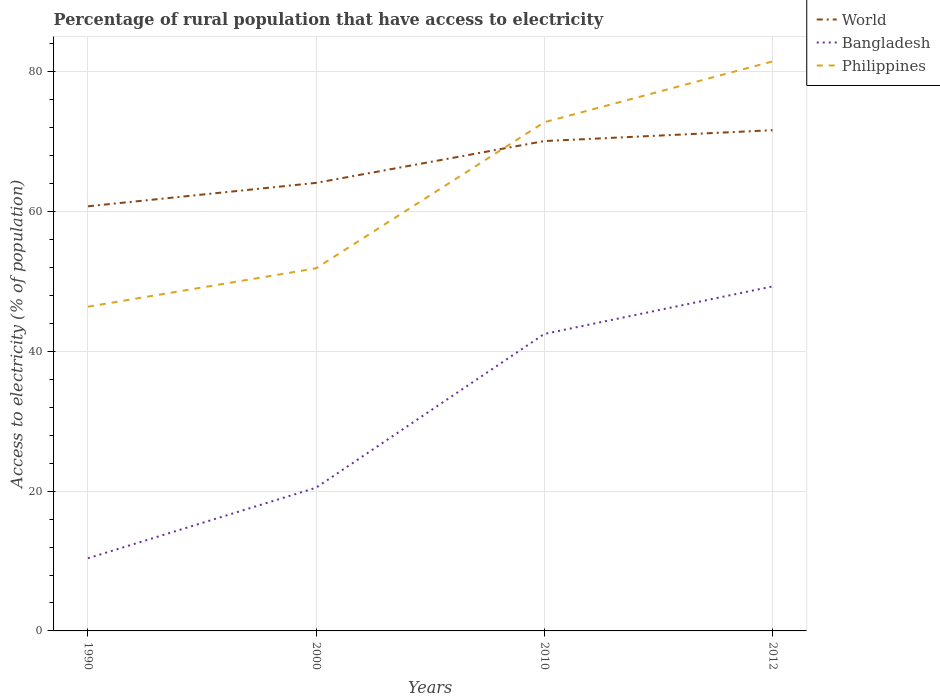How many different coloured lines are there?
Provide a short and direct response. 3. Does the line corresponding to Philippines intersect with the line corresponding to Bangladesh?
Offer a terse response. No. What is the total percentage of rural population that have access to electricity in Bangladesh in the graph?
Provide a succinct answer. -32.1. What is the difference between the highest and the second highest percentage of rural population that have access to electricity in Bangladesh?
Offer a very short reply. 38.9. What is the difference between the highest and the lowest percentage of rural population that have access to electricity in World?
Your response must be concise. 2. How many lines are there?
Keep it short and to the point. 3. What is the difference between two consecutive major ticks on the Y-axis?
Your answer should be compact. 20. Are the values on the major ticks of Y-axis written in scientific E-notation?
Ensure brevity in your answer.  No. Does the graph contain any zero values?
Your answer should be compact. No. Does the graph contain grids?
Ensure brevity in your answer.  Yes. How many legend labels are there?
Your response must be concise. 3. What is the title of the graph?
Keep it short and to the point. Percentage of rural population that have access to electricity. What is the label or title of the X-axis?
Provide a short and direct response. Years. What is the label or title of the Y-axis?
Ensure brevity in your answer.  Access to electricity (% of population). What is the Access to electricity (% of population) in World in 1990?
Your response must be concise. 60.77. What is the Access to electricity (% of population) in Bangladesh in 1990?
Your response must be concise. 10.4. What is the Access to electricity (% of population) of Philippines in 1990?
Your response must be concise. 46.4. What is the Access to electricity (% of population) of World in 2000?
Provide a short and direct response. 64.12. What is the Access to electricity (% of population) in Philippines in 2000?
Provide a succinct answer. 51.9. What is the Access to electricity (% of population) in World in 2010?
Your answer should be compact. 70.1. What is the Access to electricity (% of population) in Bangladesh in 2010?
Your response must be concise. 42.5. What is the Access to electricity (% of population) in Philippines in 2010?
Your answer should be very brief. 72.8. What is the Access to electricity (% of population) in World in 2012?
Provide a short and direct response. 71.66. What is the Access to electricity (% of population) in Bangladesh in 2012?
Offer a very short reply. 49.3. What is the Access to electricity (% of population) of Philippines in 2012?
Offer a terse response. 81.5. Across all years, what is the maximum Access to electricity (% of population) in World?
Ensure brevity in your answer.  71.66. Across all years, what is the maximum Access to electricity (% of population) of Bangladesh?
Keep it short and to the point. 49.3. Across all years, what is the maximum Access to electricity (% of population) in Philippines?
Provide a short and direct response. 81.5. Across all years, what is the minimum Access to electricity (% of population) of World?
Provide a succinct answer. 60.77. Across all years, what is the minimum Access to electricity (% of population) in Bangladesh?
Make the answer very short. 10.4. Across all years, what is the minimum Access to electricity (% of population) of Philippines?
Provide a succinct answer. 46.4. What is the total Access to electricity (% of population) of World in the graph?
Your response must be concise. 266.65. What is the total Access to electricity (% of population) of Bangladesh in the graph?
Keep it short and to the point. 122.7. What is the total Access to electricity (% of population) in Philippines in the graph?
Make the answer very short. 252.6. What is the difference between the Access to electricity (% of population) in World in 1990 and that in 2000?
Provide a succinct answer. -3.35. What is the difference between the Access to electricity (% of population) in World in 1990 and that in 2010?
Give a very brief answer. -9.34. What is the difference between the Access to electricity (% of population) of Bangladesh in 1990 and that in 2010?
Provide a short and direct response. -32.1. What is the difference between the Access to electricity (% of population) of Philippines in 1990 and that in 2010?
Offer a terse response. -26.4. What is the difference between the Access to electricity (% of population) of World in 1990 and that in 2012?
Ensure brevity in your answer.  -10.89. What is the difference between the Access to electricity (% of population) of Bangladesh in 1990 and that in 2012?
Offer a terse response. -38.9. What is the difference between the Access to electricity (% of population) of Philippines in 1990 and that in 2012?
Make the answer very short. -35.1. What is the difference between the Access to electricity (% of population) in World in 2000 and that in 2010?
Offer a very short reply. -5.98. What is the difference between the Access to electricity (% of population) of Bangladesh in 2000 and that in 2010?
Give a very brief answer. -22. What is the difference between the Access to electricity (% of population) in Philippines in 2000 and that in 2010?
Keep it short and to the point. -20.9. What is the difference between the Access to electricity (% of population) in World in 2000 and that in 2012?
Offer a terse response. -7.54. What is the difference between the Access to electricity (% of population) of Bangladesh in 2000 and that in 2012?
Ensure brevity in your answer.  -28.8. What is the difference between the Access to electricity (% of population) of Philippines in 2000 and that in 2012?
Keep it short and to the point. -29.6. What is the difference between the Access to electricity (% of population) of World in 2010 and that in 2012?
Your answer should be very brief. -1.56. What is the difference between the Access to electricity (% of population) of Bangladesh in 2010 and that in 2012?
Offer a very short reply. -6.8. What is the difference between the Access to electricity (% of population) of Philippines in 2010 and that in 2012?
Offer a very short reply. -8.7. What is the difference between the Access to electricity (% of population) of World in 1990 and the Access to electricity (% of population) of Bangladesh in 2000?
Offer a very short reply. 40.27. What is the difference between the Access to electricity (% of population) of World in 1990 and the Access to electricity (% of population) of Philippines in 2000?
Offer a terse response. 8.87. What is the difference between the Access to electricity (% of population) of Bangladesh in 1990 and the Access to electricity (% of population) of Philippines in 2000?
Offer a terse response. -41.5. What is the difference between the Access to electricity (% of population) of World in 1990 and the Access to electricity (% of population) of Bangladesh in 2010?
Your answer should be very brief. 18.27. What is the difference between the Access to electricity (% of population) of World in 1990 and the Access to electricity (% of population) of Philippines in 2010?
Offer a very short reply. -12.03. What is the difference between the Access to electricity (% of population) in Bangladesh in 1990 and the Access to electricity (% of population) in Philippines in 2010?
Offer a very short reply. -62.4. What is the difference between the Access to electricity (% of population) in World in 1990 and the Access to electricity (% of population) in Bangladesh in 2012?
Give a very brief answer. 11.47. What is the difference between the Access to electricity (% of population) of World in 1990 and the Access to electricity (% of population) of Philippines in 2012?
Your answer should be very brief. -20.73. What is the difference between the Access to electricity (% of population) of Bangladesh in 1990 and the Access to electricity (% of population) of Philippines in 2012?
Your answer should be compact. -71.1. What is the difference between the Access to electricity (% of population) of World in 2000 and the Access to electricity (% of population) of Bangladesh in 2010?
Offer a very short reply. 21.62. What is the difference between the Access to electricity (% of population) in World in 2000 and the Access to electricity (% of population) in Philippines in 2010?
Your answer should be compact. -8.68. What is the difference between the Access to electricity (% of population) in Bangladesh in 2000 and the Access to electricity (% of population) in Philippines in 2010?
Your answer should be very brief. -52.3. What is the difference between the Access to electricity (% of population) in World in 2000 and the Access to electricity (% of population) in Bangladesh in 2012?
Your response must be concise. 14.82. What is the difference between the Access to electricity (% of population) in World in 2000 and the Access to electricity (% of population) in Philippines in 2012?
Your response must be concise. -17.38. What is the difference between the Access to electricity (% of population) of Bangladesh in 2000 and the Access to electricity (% of population) of Philippines in 2012?
Give a very brief answer. -61. What is the difference between the Access to electricity (% of population) of World in 2010 and the Access to electricity (% of population) of Bangladesh in 2012?
Your response must be concise. 20.8. What is the difference between the Access to electricity (% of population) in World in 2010 and the Access to electricity (% of population) in Philippines in 2012?
Offer a terse response. -11.4. What is the difference between the Access to electricity (% of population) in Bangladesh in 2010 and the Access to electricity (% of population) in Philippines in 2012?
Offer a very short reply. -39. What is the average Access to electricity (% of population) of World per year?
Make the answer very short. 66.66. What is the average Access to electricity (% of population) of Bangladesh per year?
Give a very brief answer. 30.68. What is the average Access to electricity (% of population) in Philippines per year?
Make the answer very short. 63.15. In the year 1990, what is the difference between the Access to electricity (% of population) in World and Access to electricity (% of population) in Bangladesh?
Make the answer very short. 50.37. In the year 1990, what is the difference between the Access to electricity (% of population) of World and Access to electricity (% of population) of Philippines?
Ensure brevity in your answer.  14.37. In the year 1990, what is the difference between the Access to electricity (% of population) in Bangladesh and Access to electricity (% of population) in Philippines?
Keep it short and to the point. -36. In the year 2000, what is the difference between the Access to electricity (% of population) in World and Access to electricity (% of population) in Bangladesh?
Your answer should be compact. 43.62. In the year 2000, what is the difference between the Access to electricity (% of population) of World and Access to electricity (% of population) of Philippines?
Offer a very short reply. 12.22. In the year 2000, what is the difference between the Access to electricity (% of population) of Bangladesh and Access to electricity (% of population) of Philippines?
Offer a terse response. -31.4. In the year 2010, what is the difference between the Access to electricity (% of population) of World and Access to electricity (% of population) of Bangladesh?
Provide a short and direct response. 27.6. In the year 2010, what is the difference between the Access to electricity (% of population) of World and Access to electricity (% of population) of Philippines?
Give a very brief answer. -2.7. In the year 2010, what is the difference between the Access to electricity (% of population) in Bangladesh and Access to electricity (% of population) in Philippines?
Ensure brevity in your answer.  -30.3. In the year 2012, what is the difference between the Access to electricity (% of population) in World and Access to electricity (% of population) in Bangladesh?
Offer a very short reply. 22.36. In the year 2012, what is the difference between the Access to electricity (% of population) of World and Access to electricity (% of population) of Philippines?
Provide a short and direct response. -9.84. In the year 2012, what is the difference between the Access to electricity (% of population) in Bangladesh and Access to electricity (% of population) in Philippines?
Offer a very short reply. -32.2. What is the ratio of the Access to electricity (% of population) of World in 1990 to that in 2000?
Give a very brief answer. 0.95. What is the ratio of the Access to electricity (% of population) in Bangladesh in 1990 to that in 2000?
Provide a short and direct response. 0.51. What is the ratio of the Access to electricity (% of population) in Philippines in 1990 to that in 2000?
Offer a terse response. 0.89. What is the ratio of the Access to electricity (% of population) of World in 1990 to that in 2010?
Provide a short and direct response. 0.87. What is the ratio of the Access to electricity (% of population) of Bangladesh in 1990 to that in 2010?
Your response must be concise. 0.24. What is the ratio of the Access to electricity (% of population) in Philippines in 1990 to that in 2010?
Your answer should be very brief. 0.64. What is the ratio of the Access to electricity (% of population) of World in 1990 to that in 2012?
Keep it short and to the point. 0.85. What is the ratio of the Access to electricity (% of population) in Bangladesh in 1990 to that in 2012?
Keep it short and to the point. 0.21. What is the ratio of the Access to electricity (% of population) of Philippines in 1990 to that in 2012?
Make the answer very short. 0.57. What is the ratio of the Access to electricity (% of population) in World in 2000 to that in 2010?
Ensure brevity in your answer.  0.91. What is the ratio of the Access to electricity (% of population) in Bangladesh in 2000 to that in 2010?
Your answer should be very brief. 0.48. What is the ratio of the Access to electricity (% of population) of Philippines in 2000 to that in 2010?
Provide a short and direct response. 0.71. What is the ratio of the Access to electricity (% of population) of World in 2000 to that in 2012?
Provide a succinct answer. 0.89. What is the ratio of the Access to electricity (% of population) of Bangladesh in 2000 to that in 2012?
Offer a terse response. 0.42. What is the ratio of the Access to electricity (% of population) in Philippines in 2000 to that in 2012?
Your answer should be very brief. 0.64. What is the ratio of the Access to electricity (% of population) in World in 2010 to that in 2012?
Offer a very short reply. 0.98. What is the ratio of the Access to electricity (% of population) in Bangladesh in 2010 to that in 2012?
Your response must be concise. 0.86. What is the ratio of the Access to electricity (% of population) of Philippines in 2010 to that in 2012?
Offer a very short reply. 0.89. What is the difference between the highest and the second highest Access to electricity (% of population) of World?
Keep it short and to the point. 1.56. What is the difference between the highest and the lowest Access to electricity (% of population) in World?
Offer a very short reply. 10.89. What is the difference between the highest and the lowest Access to electricity (% of population) in Bangladesh?
Your answer should be very brief. 38.9. What is the difference between the highest and the lowest Access to electricity (% of population) of Philippines?
Make the answer very short. 35.1. 